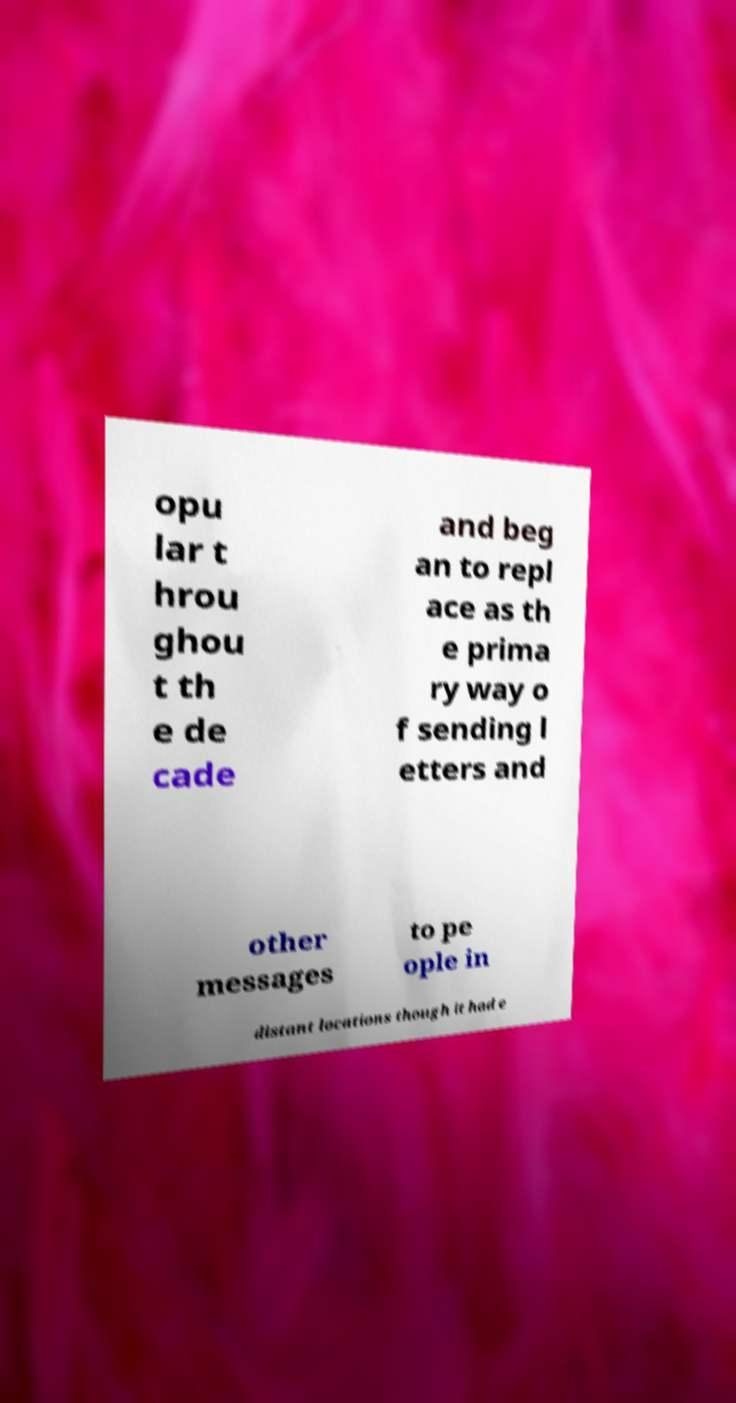Could you extract and type out the text from this image? opu lar t hrou ghou t th e de cade and beg an to repl ace as th e prima ry way o f sending l etters and other messages to pe ople in distant locations though it had e 